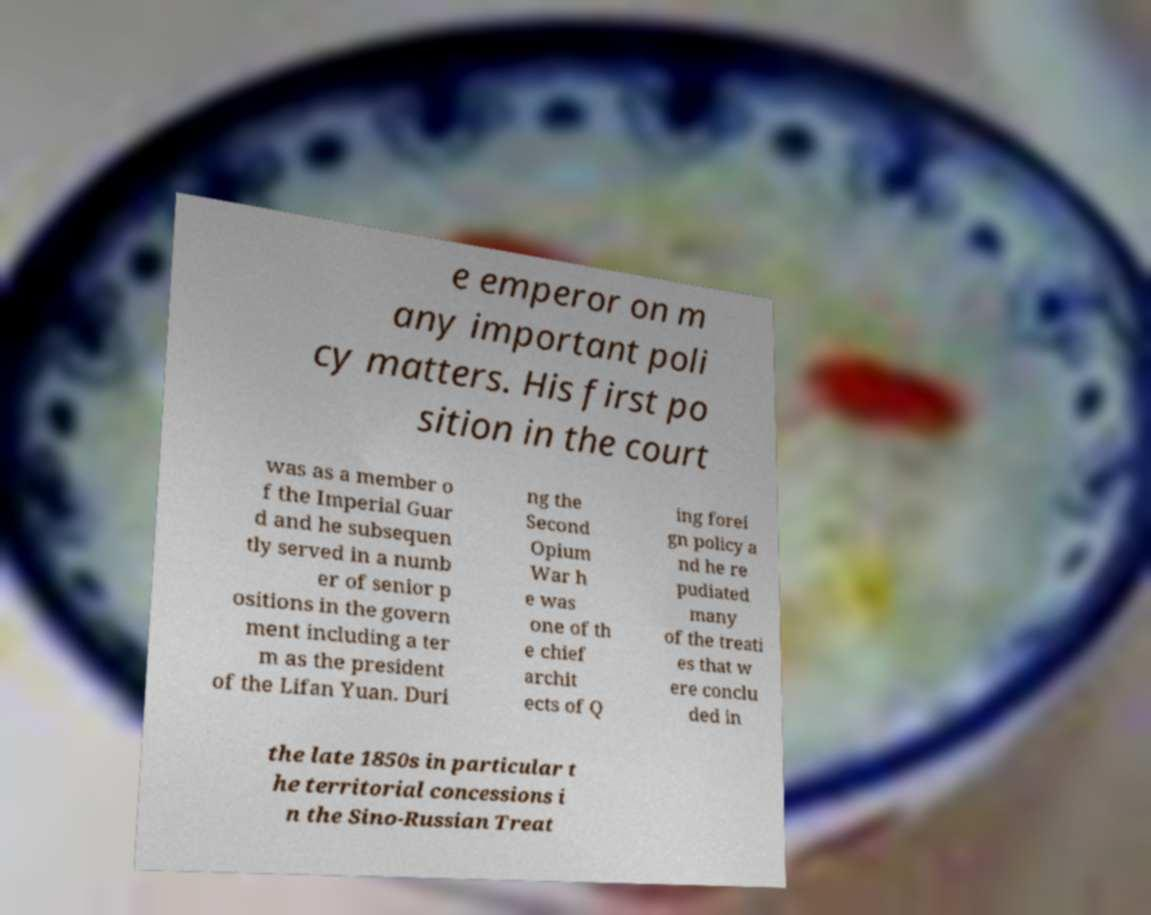Please identify and transcribe the text found in this image. e emperor on m any important poli cy matters. His first po sition in the court was as a member o f the Imperial Guar d and he subsequen tly served in a numb er of senior p ositions in the govern ment including a ter m as the president of the Lifan Yuan. Duri ng the Second Opium War h e was one of th e chief archit ects of Q ing forei gn policy a nd he re pudiated many of the treati es that w ere conclu ded in the late 1850s in particular t he territorial concessions i n the Sino-Russian Treat 